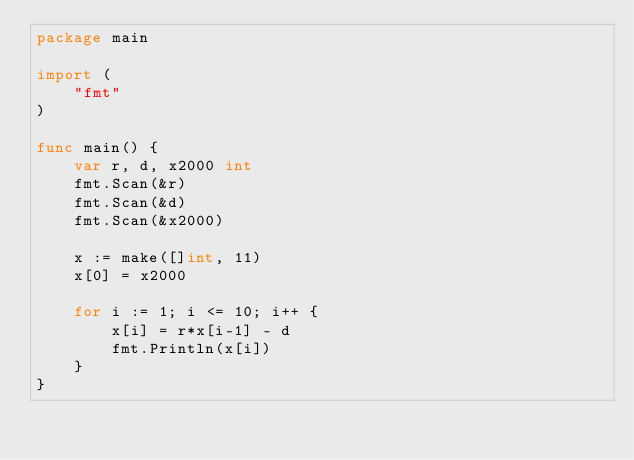<code> <loc_0><loc_0><loc_500><loc_500><_Go_>package main

import (
	"fmt"
)

func main() {
	var r, d, x2000 int
	fmt.Scan(&r)
	fmt.Scan(&d)
	fmt.Scan(&x2000)

	x := make([]int, 11)
	x[0] = x2000

	for i := 1; i <= 10; i++ {
		x[i] = r*x[i-1] - d
		fmt.Println(x[i])
	}
}
</code> 